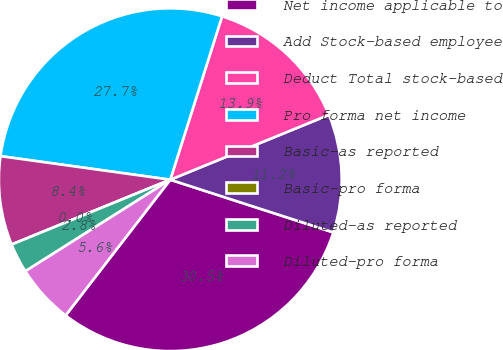Convert chart to OTSL. <chart><loc_0><loc_0><loc_500><loc_500><pie_chart><fcel>Net income applicable to<fcel>Add Stock-based employee<fcel>Deduct Total stock-based<fcel>Pro forma net income<fcel>Basic-as reported<fcel>Basic-pro forma<fcel>Diluted-as reported<fcel>Diluted-pro forma<nl><fcel>30.48%<fcel>11.15%<fcel>13.94%<fcel>27.69%<fcel>8.37%<fcel>0.0%<fcel>2.79%<fcel>5.58%<nl></chart> 